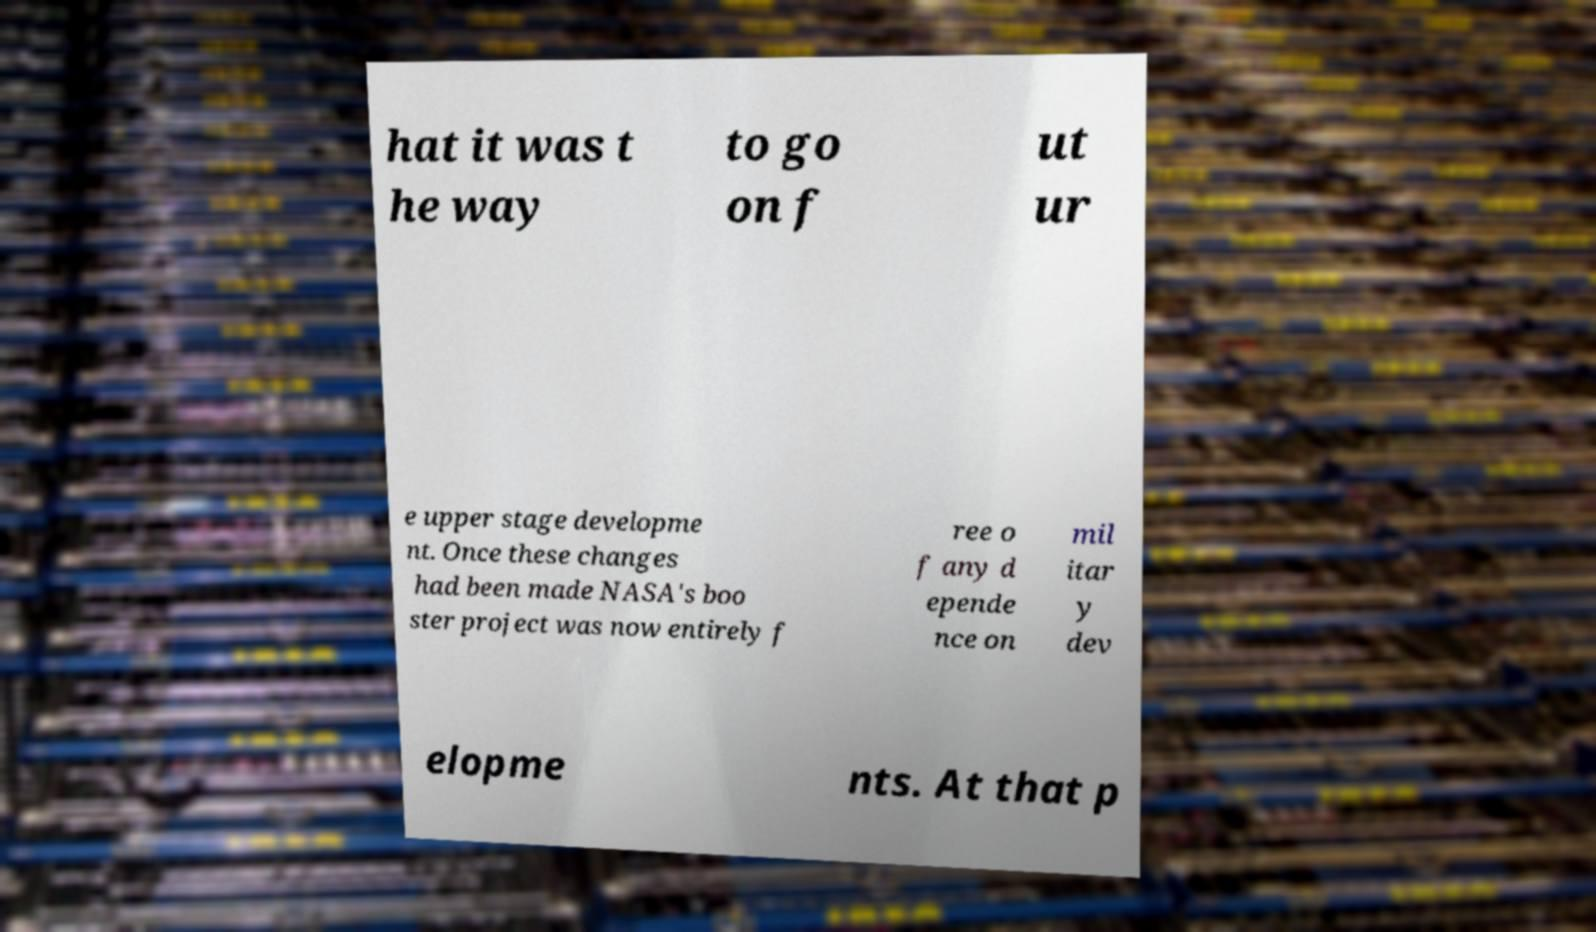Please read and relay the text visible in this image. What does it say? hat it was t he way to go on f ut ur e upper stage developme nt. Once these changes had been made NASA's boo ster project was now entirely f ree o f any d epende nce on mil itar y dev elopme nts. At that p 